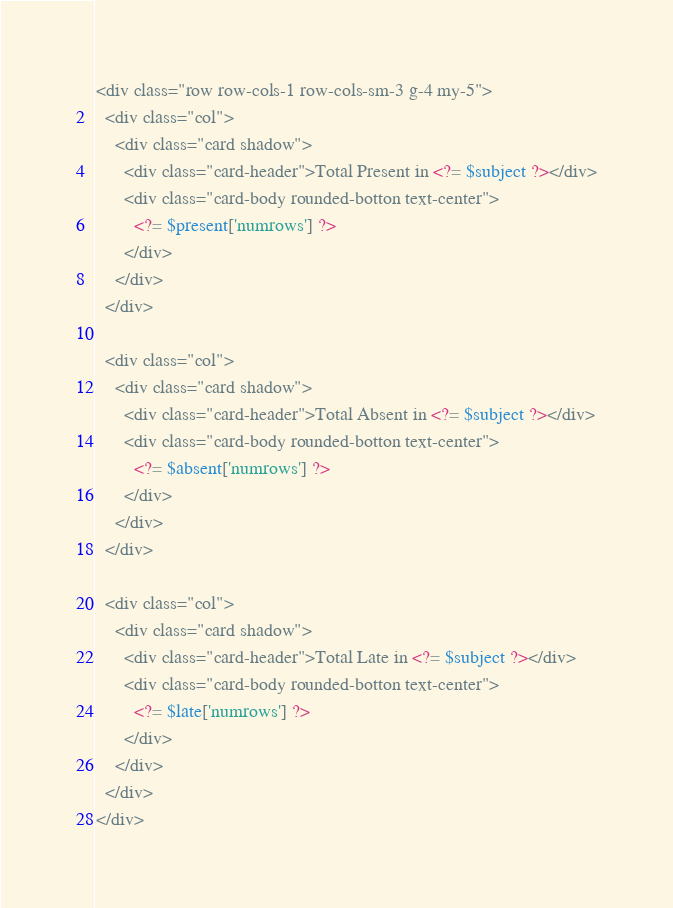<code> <loc_0><loc_0><loc_500><loc_500><_PHP_><div class="row row-cols-1 row-cols-sm-3 g-4 my-5">
  <div class="col">
    <div class="card shadow">
      <div class="card-header">Total Present in <?= $subject ?></div>
      <div class="card-body rounded-botton text-center">
        <?= $present['numrows'] ?>
      </div>
    </div>
  </div>

  <div class="col">
    <div class="card shadow">
      <div class="card-header">Total Absent in <?= $subject ?></div>
      <div class="card-body rounded-botton text-center">
        <?= $absent['numrows'] ?>
      </div>
    </div>
  </div>

  <div class="col">
    <div class="card shadow">
      <div class="card-header">Total Late in <?= $subject ?></div>
      <div class="card-body rounded-botton text-center">
        <?= $late['numrows'] ?>
      </div>
    </div>
  </div>
</div></code> 